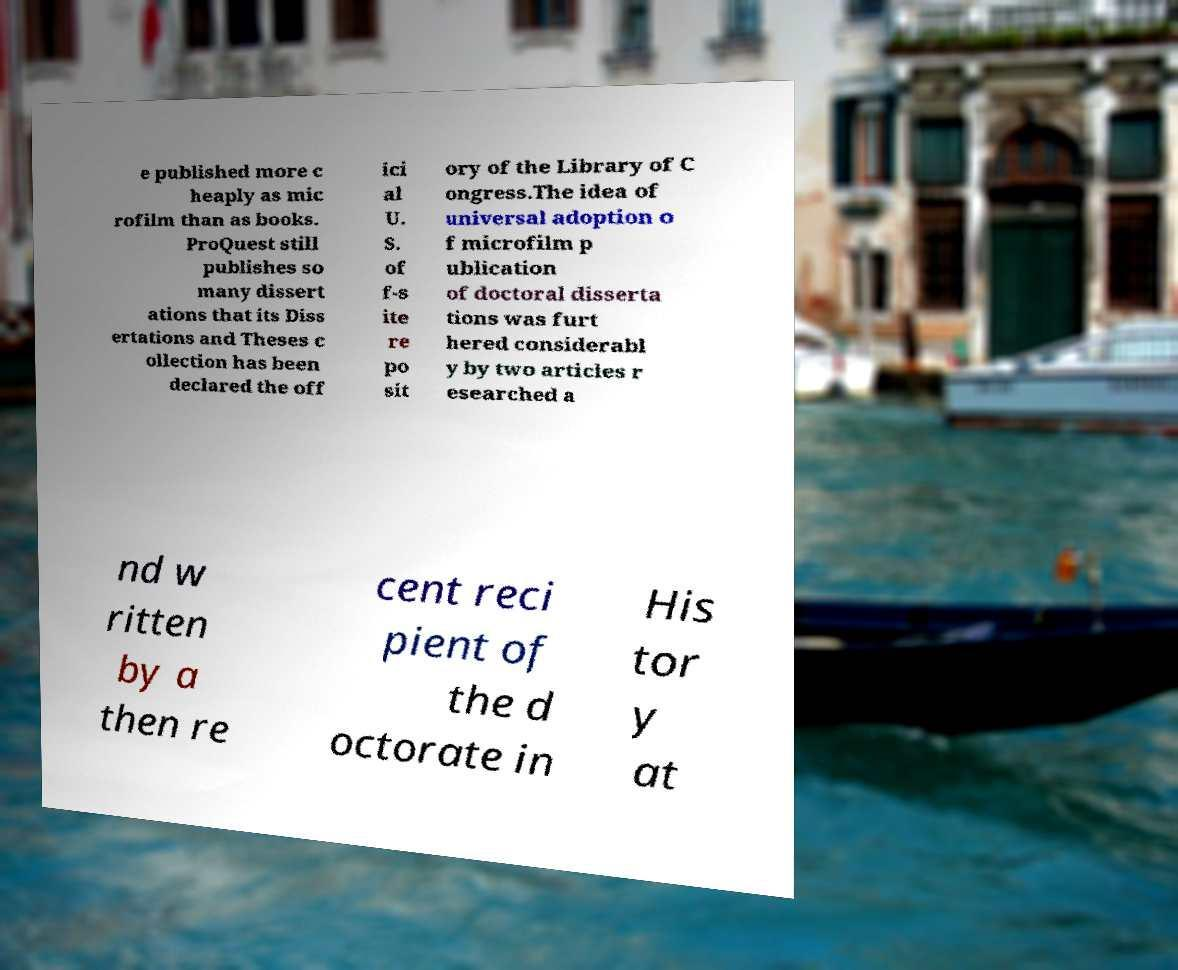Could you assist in decoding the text presented in this image and type it out clearly? e published more c heaply as mic rofilm than as books. ProQuest still publishes so many dissert ations that its Diss ertations and Theses c ollection has been declared the off ici al U. S. of f-s ite re po sit ory of the Library of C ongress.The idea of universal adoption o f microfilm p ublication of doctoral disserta tions was furt hered considerabl y by two articles r esearched a nd w ritten by a then re cent reci pient of the d octorate in His tor y at 